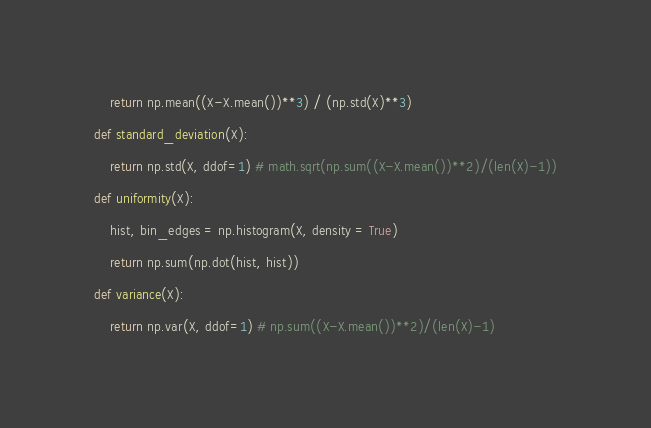Convert code to text. <code><loc_0><loc_0><loc_500><loc_500><_Python_>    return np.mean((X-X.mean())**3) / (np.std(X)**3)

def standard_deviation(X):

    return np.std(X, ddof=1) # math.sqrt(np.sum((X-X.mean())**2)/(len(X)-1))

def uniformity(X):

    hist, bin_edges = np.histogram(X, density = True)

    return np.sum(np.dot(hist, hist))

def variance(X):

    return np.var(X, ddof=1) # np.sum((X-X.mean())**2)/(len(X)-1)</code> 